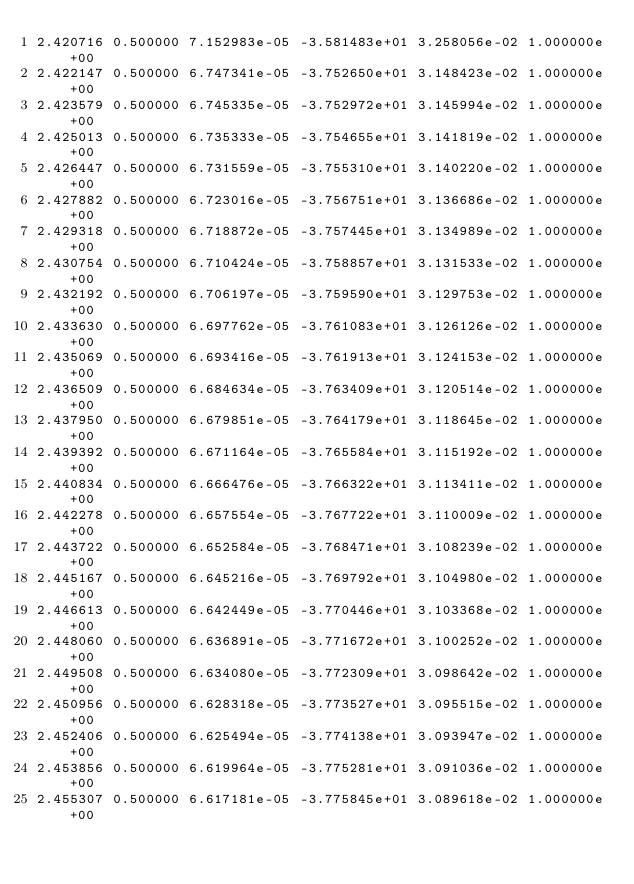Convert code to text. <code><loc_0><loc_0><loc_500><loc_500><_SQL_>2.420716 0.500000 7.152983e-05 -3.581483e+01 3.258056e-02 1.000000e+00 
2.422147 0.500000 6.747341e-05 -3.752650e+01 3.148423e-02 1.000000e+00 
2.423579 0.500000 6.745335e-05 -3.752972e+01 3.145994e-02 1.000000e+00 
2.425013 0.500000 6.735333e-05 -3.754655e+01 3.141819e-02 1.000000e+00 
2.426447 0.500000 6.731559e-05 -3.755310e+01 3.140220e-02 1.000000e+00 
2.427882 0.500000 6.723016e-05 -3.756751e+01 3.136686e-02 1.000000e+00 
2.429318 0.500000 6.718872e-05 -3.757445e+01 3.134989e-02 1.000000e+00 
2.430754 0.500000 6.710424e-05 -3.758857e+01 3.131533e-02 1.000000e+00 
2.432192 0.500000 6.706197e-05 -3.759590e+01 3.129753e-02 1.000000e+00 
2.433630 0.500000 6.697762e-05 -3.761083e+01 3.126126e-02 1.000000e+00 
2.435069 0.500000 6.693416e-05 -3.761913e+01 3.124153e-02 1.000000e+00 
2.436509 0.500000 6.684634e-05 -3.763409e+01 3.120514e-02 1.000000e+00 
2.437950 0.500000 6.679851e-05 -3.764179e+01 3.118645e-02 1.000000e+00 
2.439392 0.500000 6.671164e-05 -3.765584e+01 3.115192e-02 1.000000e+00 
2.440834 0.500000 6.666476e-05 -3.766322e+01 3.113411e-02 1.000000e+00 
2.442278 0.500000 6.657554e-05 -3.767722e+01 3.110009e-02 1.000000e+00 
2.443722 0.500000 6.652584e-05 -3.768471e+01 3.108239e-02 1.000000e+00 
2.445167 0.500000 6.645216e-05 -3.769792e+01 3.104980e-02 1.000000e+00 
2.446613 0.500000 6.642449e-05 -3.770446e+01 3.103368e-02 1.000000e+00 
2.448060 0.500000 6.636891e-05 -3.771672e+01 3.100252e-02 1.000000e+00 
2.449508 0.500000 6.634080e-05 -3.772309e+01 3.098642e-02 1.000000e+00 
2.450956 0.500000 6.628318e-05 -3.773527e+01 3.095515e-02 1.000000e+00 
2.452406 0.500000 6.625494e-05 -3.774138e+01 3.093947e-02 1.000000e+00 
2.453856 0.500000 6.619964e-05 -3.775281e+01 3.091036e-02 1.000000e+00 
2.455307 0.500000 6.617181e-05 -3.775845e+01 3.089618e-02 1.000000e+00 </code> 